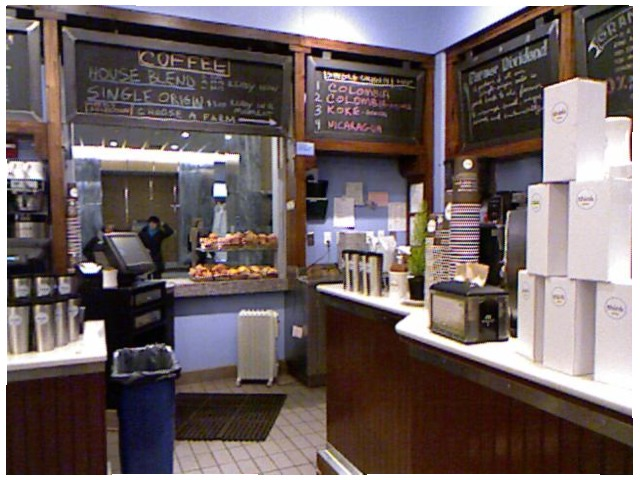<image>
Can you confirm if the menu board is above the snacks? Yes. The menu board is positioned above the snacks in the vertical space, higher up in the scene. Is the plastic bag in the trashcan? Yes. The plastic bag is contained within or inside the trashcan, showing a containment relationship. 